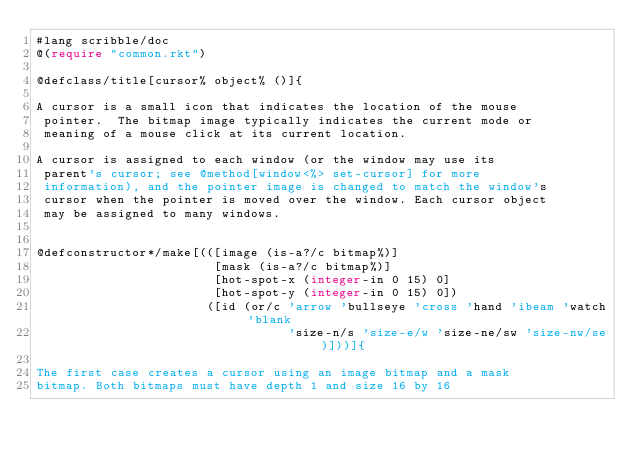Convert code to text. <code><loc_0><loc_0><loc_500><loc_500><_Racket_>#lang scribble/doc
@(require "common.rkt")

@defclass/title[cursor% object% ()]{

A cursor is a small icon that indicates the location of the mouse
 pointer.  The bitmap image typically indicates the current mode or
 meaning of a mouse click at its current location.

A cursor is assigned to each window (or the window may use its
 parent's cursor; see @method[window<%> set-cursor] for more
 information), and the pointer image is changed to match the window's
 cursor when the pointer is moved over the window. Each cursor object
 may be assigned to many windows.


@defconstructor*/make[(([image (is-a?/c bitmap%)]
                        [mask (is-a?/c bitmap%)]
                        [hot-spot-x (integer-in 0 15) 0]
                        [hot-spot-y (integer-in 0 15) 0])
                       ([id (or/c 'arrow 'bullseye 'cross 'hand 'ibeam 'watch 'blank 
                                  'size-n/s 'size-e/w 'size-ne/sw 'size-nw/se)]))]{

The first case creates a cursor using an image bitmap and a mask
bitmap. Both bitmaps must have depth 1 and size 16 by 16</code> 